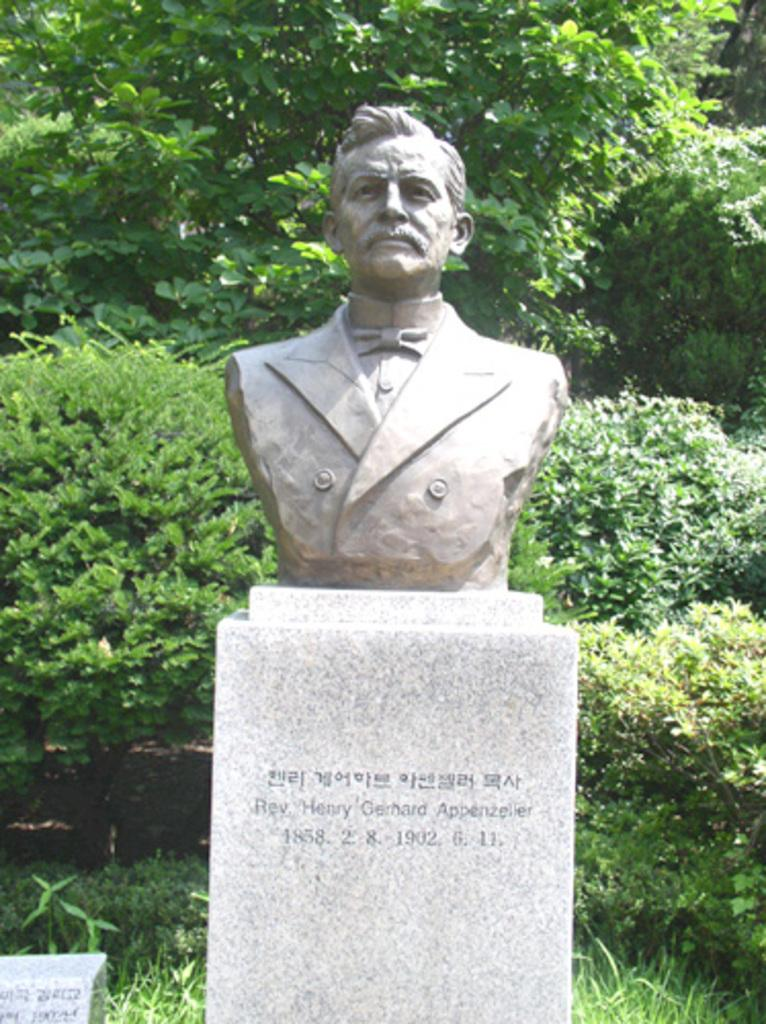What is the main subject of the image? There is a statue in the image. What can be seen in the background of the image? There are trees in the background of the image. What type of insurance policy is being discussed in the image? There is no mention of insurance in the image, as it features a statue and trees in the background. In which bedroom is the statue located in the image? The image does not show a bedroom, nor does it provide any information about the location of the statue within a specific room. 